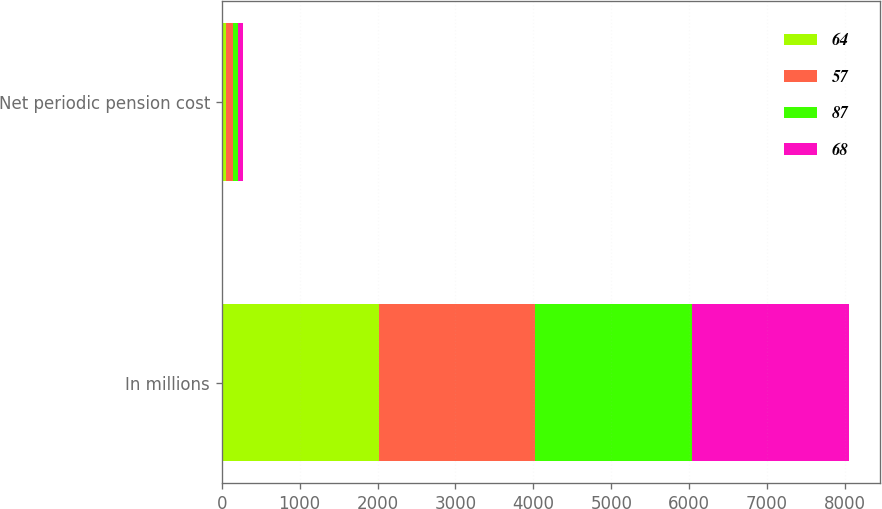Convert chart to OTSL. <chart><loc_0><loc_0><loc_500><loc_500><stacked_bar_chart><ecel><fcel>In millions<fcel>Net periodic pension cost<nl><fcel>64<fcel>2014<fcel>57<nl><fcel>57<fcel>2013<fcel>87<nl><fcel>87<fcel>2012<fcel>64<nl><fcel>68<fcel>2011<fcel>68<nl></chart> 